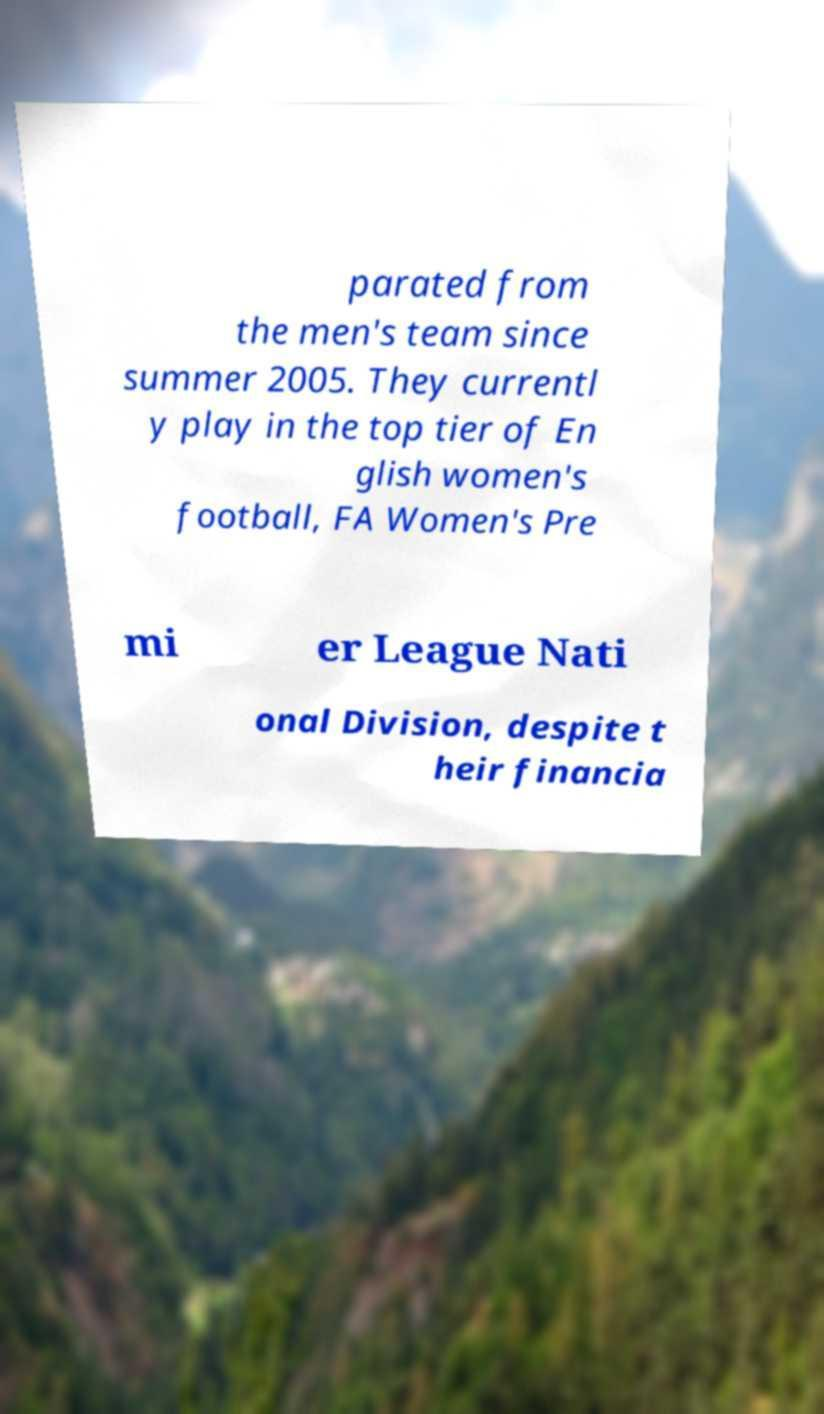There's text embedded in this image that I need extracted. Can you transcribe it verbatim? parated from the men's team since summer 2005. They currentl y play in the top tier of En glish women's football, FA Women's Pre mi er League Nati onal Division, despite t heir financia 